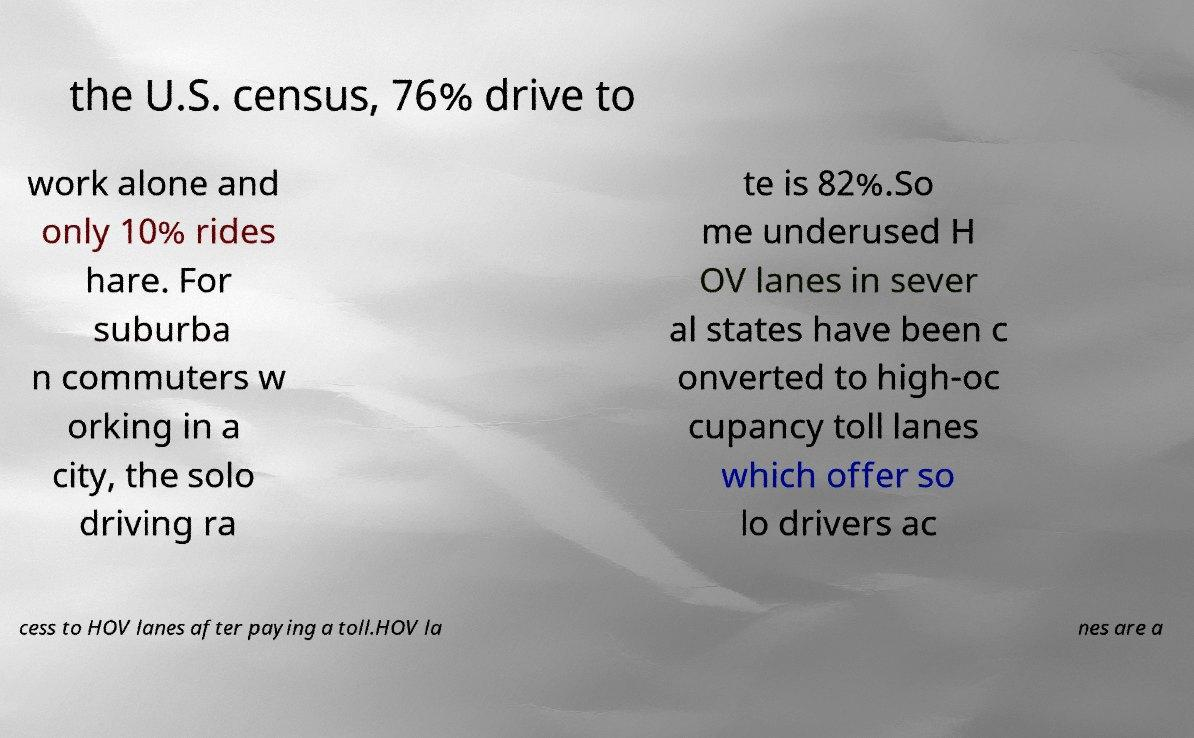There's text embedded in this image that I need extracted. Can you transcribe it verbatim? the U.S. census, 76% drive to work alone and only 10% rides hare. For suburba n commuters w orking in a city, the solo driving ra te is 82%.So me underused H OV lanes in sever al states have been c onverted to high-oc cupancy toll lanes which offer so lo drivers ac cess to HOV lanes after paying a toll.HOV la nes are a 